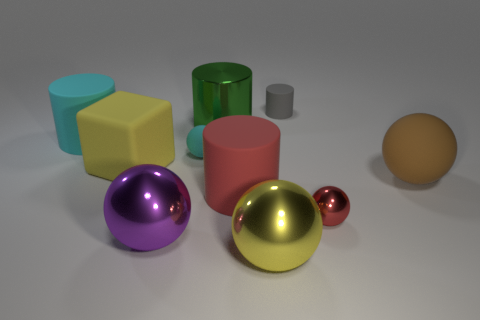Subtract all yellow spheres. How many spheres are left? 4 Subtract all tiny cyan balls. How many balls are left? 4 Subtract all gray balls. Subtract all red cubes. How many balls are left? 5 Subtract all blocks. How many objects are left? 9 Subtract all small balls. Subtract all tiny metal balls. How many objects are left? 7 Add 8 tiny rubber spheres. How many tiny rubber spheres are left? 9 Add 9 gray matte objects. How many gray matte objects exist? 10 Subtract 0 blue cubes. How many objects are left? 10 